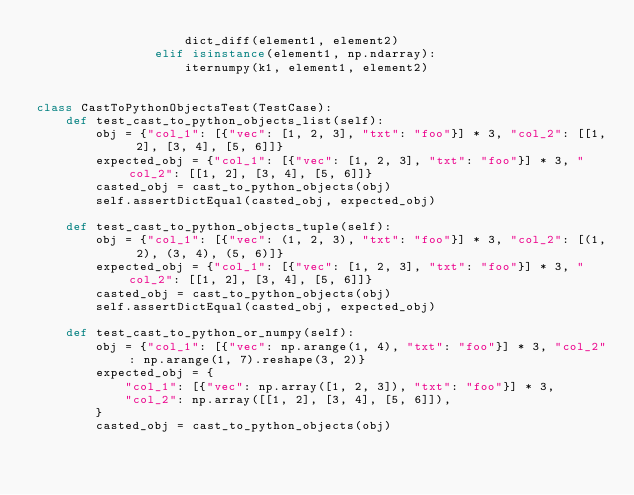Convert code to text. <code><loc_0><loc_0><loc_500><loc_500><_Python_>                    dict_diff(element1, element2)
                elif isinstance(element1, np.ndarray):
                    iternumpy(k1, element1, element2)


class CastToPythonObjectsTest(TestCase):
    def test_cast_to_python_objects_list(self):
        obj = {"col_1": [{"vec": [1, 2, 3], "txt": "foo"}] * 3, "col_2": [[1, 2], [3, 4], [5, 6]]}
        expected_obj = {"col_1": [{"vec": [1, 2, 3], "txt": "foo"}] * 3, "col_2": [[1, 2], [3, 4], [5, 6]]}
        casted_obj = cast_to_python_objects(obj)
        self.assertDictEqual(casted_obj, expected_obj)

    def test_cast_to_python_objects_tuple(self):
        obj = {"col_1": [{"vec": (1, 2, 3), "txt": "foo"}] * 3, "col_2": [(1, 2), (3, 4), (5, 6)]}
        expected_obj = {"col_1": [{"vec": [1, 2, 3], "txt": "foo"}] * 3, "col_2": [[1, 2], [3, 4], [5, 6]]}
        casted_obj = cast_to_python_objects(obj)
        self.assertDictEqual(casted_obj, expected_obj)

    def test_cast_to_python_or_numpy(self):
        obj = {"col_1": [{"vec": np.arange(1, 4), "txt": "foo"}] * 3, "col_2": np.arange(1, 7).reshape(3, 2)}
        expected_obj = {
            "col_1": [{"vec": np.array([1, 2, 3]), "txt": "foo"}] * 3,
            "col_2": np.array([[1, 2], [3, 4], [5, 6]]),
        }
        casted_obj = cast_to_python_objects(obj)</code> 